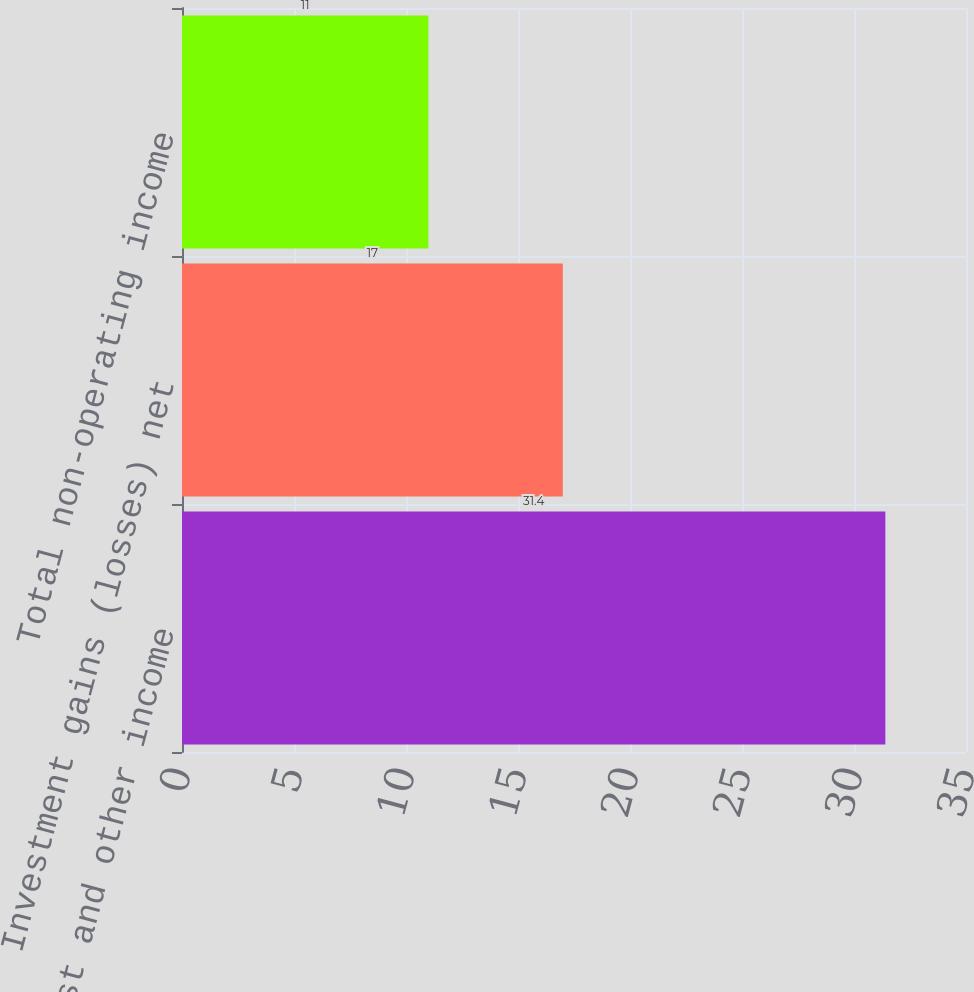Convert chart to OTSL. <chart><loc_0><loc_0><loc_500><loc_500><bar_chart><fcel>Interest and other income<fcel>Investment gains (losses) net<fcel>Total non-operating income<nl><fcel>31.4<fcel>17<fcel>11<nl></chart> 